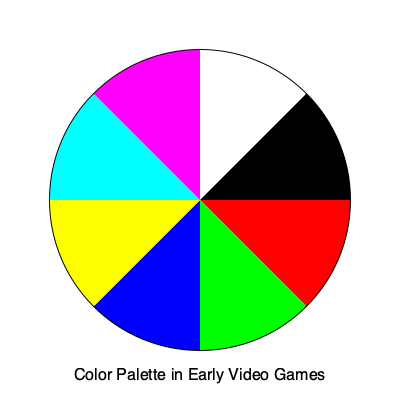In the early days of video game development, particularly during the era of Doom's release, what was the typical number of colors available in the standard VGA palette, as represented in the pie chart above? To answer this question, we need to analyze the pie chart and recall the color limitations of early video games:

1. The pie chart is divided into 8 equal sections, each representing a different color.

2. These colors are: Red, Green, Blue, Yellow, Cyan, Magenta, White, and Black.

3. This color scheme is reminiscent of the standard VGA (Video Graphics Array) palette used in early PC games, including Doom.

4. The VGA standard, introduced in 1987, supported a 256-color palette.

5. However, game developers often used a subset of this palette to optimize performance and memory usage.

6. The most common subset was the 16-color palette, which included these 8 basic colors plus 8 additional shades.

7. In the case of Doom, released in 1993, it actually used a 256-color palette, but the core colors were based on this fundamental 8-color set.

8. The pie chart represents these 8 core colors, which formed the basis of many early video game color schemes.

Therefore, while the full VGA palette supported 256 colors, the fundamental set of colors as shown in the pie chart, which was often used as a base for early video games like Doom, contained 8 colors.
Answer: 8 colors 